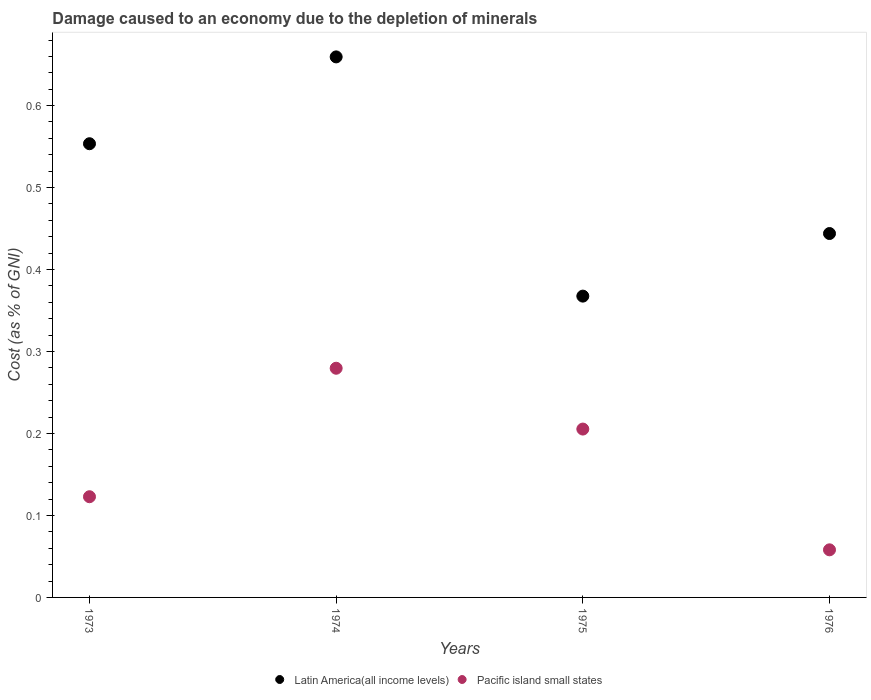Is the number of dotlines equal to the number of legend labels?
Provide a succinct answer. Yes. What is the cost of damage caused due to the depletion of minerals in Pacific island small states in 1976?
Provide a short and direct response. 0.06. Across all years, what is the maximum cost of damage caused due to the depletion of minerals in Latin America(all income levels)?
Your answer should be compact. 0.66. Across all years, what is the minimum cost of damage caused due to the depletion of minerals in Latin America(all income levels)?
Offer a terse response. 0.37. In which year was the cost of damage caused due to the depletion of minerals in Latin America(all income levels) maximum?
Your answer should be very brief. 1974. In which year was the cost of damage caused due to the depletion of minerals in Pacific island small states minimum?
Offer a very short reply. 1976. What is the total cost of damage caused due to the depletion of minerals in Latin America(all income levels) in the graph?
Provide a succinct answer. 2.02. What is the difference between the cost of damage caused due to the depletion of minerals in Latin America(all income levels) in 1973 and that in 1976?
Provide a succinct answer. 0.11. What is the difference between the cost of damage caused due to the depletion of minerals in Pacific island small states in 1973 and the cost of damage caused due to the depletion of minerals in Latin America(all income levels) in 1975?
Your response must be concise. -0.24. What is the average cost of damage caused due to the depletion of minerals in Pacific island small states per year?
Make the answer very short. 0.17. In the year 1976, what is the difference between the cost of damage caused due to the depletion of minerals in Pacific island small states and cost of damage caused due to the depletion of minerals in Latin America(all income levels)?
Provide a short and direct response. -0.39. What is the ratio of the cost of damage caused due to the depletion of minerals in Latin America(all income levels) in 1974 to that in 1975?
Keep it short and to the point. 1.79. What is the difference between the highest and the second highest cost of damage caused due to the depletion of minerals in Latin America(all income levels)?
Offer a terse response. 0.11. What is the difference between the highest and the lowest cost of damage caused due to the depletion of minerals in Latin America(all income levels)?
Ensure brevity in your answer.  0.29. In how many years, is the cost of damage caused due to the depletion of minerals in Pacific island small states greater than the average cost of damage caused due to the depletion of minerals in Pacific island small states taken over all years?
Give a very brief answer. 2. Is the cost of damage caused due to the depletion of minerals in Latin America(all income levels) strictly greater than the cost of damage caused due to the depletion of minerals in Pacific island small states over the years?
Offer a terse response. Yes. Does the graph contain any zero values?
Your answer should be compact. No. Where does the legend appear in the graph?
Make the answer very short. Bottom center. What is the title of the graph?
Provide a succinct answer. Damage caused to an economy due to the depletion of minerals. What is the label or title of the X-axis?
Your response must be concise. Years. What is the label or title of the Y-axis?
Your response must be concise. Cost (as % of GNI). What is the Cost (as % of GNI) in Latin America(all income levels) in 1973?
Keep it short and to the point. 0.55. What is the Cost (as % of GNI) of Pacific island small states in 1973?
Give a very brief answer. 0.12. What is the Cost (as % of GNI) in Latin America(all income levels) in 1974?
Your response must be concise. 0.66. What is the Cost (as % of GNI) in Pacific island small states in 1974?
Your answer should be compact. 0.28. What is the Cost (as % of GNI) of Latin America(all income levels) in 1975?
Offer a very short reply. 0.37. What is the Cost (as % of GNI) in Pacific island small states in 1975?
Keep it short and to the point. 0.21. What is the Cost (as % of GNI) of Latin America(all income levels) in 1976?
Give a very brief answer. 0.44. What is the Cost (as % of GNI) in Pacific island small states in 1976?
Offer a terse response. 0.06. Across all years, what is the maximum Cost (as % of GNI) in Latin America(all income levels)?
Your answer should be very brief. 0.66. Across all years, what is the maximum Cost (as % of GNI) of Pacific island small states?
Keep it short and to the point. 0.28. Across all years, what is the minimum Cost (as % of GNI) in Latin America(all income levels)?
Offer a very short reply. 0.37. Across all years, what is the minimum Cost (as % of GNI) of Pacific island small states?
Offer a very short reply. 0.06. What is the total Cost (as % of GNI) of Latin America(all income levels) in the graph?
Provide a succinct answer. 2.02. What is the total Cost (as % of GNI) in Pacific island small states in the graph?
Your answer should be very brief. 0.67. What is the difference between the Cost (as % of GNI) of Latin America(all income levels) in 1973 and that in 1974?
Provide a short and direct response. -0.11. What is the difference between the Cost (as % of GNI) of Pacific island small states in 1973 and that in 1974?
Make the answer very short. -0.16. What is the difference between the Cost (as % of GNI) of Latin America(all income levels) in 1973 and that in 1975?
Make the answer very short. 0.19. What is the difference between the Cost (as % of GNI) in Pacific island small states in 1973 and that in 1975?
Provide a short and direct response. -0.08. What is the difference between the Cost (as % of GNI) in Latin America(all income levels) in 1973 and that in 1976?
Offer a very short reply. 0.11. What is the difference between the Cost (as % of GNI) in Pacific island small states in 1973 and that in 1976?
Provide a succinct answer. 0.06. What is the difference between the Cost (as % of GNI) of Latin America(all income levels) in 1974 and that in 1975?
Ensure brevity in your answer.  0.29. What is the difference between the Cost (as % of GNI) of Pacific island small states in 1974 and that in 1975?
Your response must be concise. 0.07. What is the difference between the Cost (as % of GNI) of Latin America(all income levels) in 1974 and that in 1976?
Your answer should be very brief. 0.22. What is the difference between the Cost (as % of GNI) in Pacific island small states in 1974 and that in 1976?
Ensure brevity in your answer.  0.22. What is the difference between the Cost (as % of GNI) of Latin America(all income levels) in 1975 and that in 1976?
Offer a very short reply. -0.08. What is the difference between the Cost (as % of GNI) in Pacific island small states in 1975 and that in 1976?
Provide a succinct answer. 0.15. What is the difference between the Cost (as % of GNI) of Latin America(all income levels) in 1973 and the Cost (as % of GNI) of Pacific island small states in 1974?
Give a very brief answer. 0.27. What is the difference between the Cost (as % of GNI) of Latin America(all income levels) in 1973 and the Cost (as % of GNI) of Pacific island small states in 1975?
Make the answer very short. 0.35. What is the difference between the Cost (as % of GNI) in Latin America(all income levels) in 1973 and the Cost (as % of GNI) in Pacific island small states in 1976?
Give a very brief answer. 0.5. What is the difference between the Cost (as % of GNI) of Latin America(all income levels) in 1974 and the Cost (as % of GNI) of Pacific island small states in 1975?
Give a very brief answer. 0.45. What is the difference between the Cost (as % of GNI) in Latin America(all income levels) in 1974 and the Cost (as % of GNI) in Pacific island small states in 1976?
Your answer should be very brief. 0.6. What is the difference between the Cost (as % of GNI) of Latin America(all income levels) in 1975 and the Cost (as % of GNI) of Pacific island small states in 1976?
Offer a terse response. 0.31. What is the average Cost (as % of GNI) in Latin America(all income levels) per year?
Provide a succinct answer. 0.51. What is the average Cost (as % of GNI) in Pacific island small states per year?
Make the answer very short. 0.17. In the year 1973, what is the difference between the Cost (as % of GNI) in Latin America(all income levels) and Cost (as % of GNI) in Pacific island small states?
Offer a terse response. 0.43. In the year 1974, what is the difference between the Cost (as % of GNI) of Latin America(all income levels) and Cost (as % of GNI) of Pacific island small states?
Your answer should be very brief. 0.38. In the year 1975, what is the difference between the Cost (as % of GNI) in Latin America(all income levels) and Cost (as % of GNI) in Pacific island small states?
Your response must be concise. 0.16. In the year 1976, what is the difference between the Cost (as % of GNI) of Latin America(all income levels) and Cost (as % of GNI) of Pacific island small states?
Make the answer very short. 0.39. What is the ratio of the Cost (as % of GNI) of Latin America(all income levels) in 1973 to that in 1974?
Make the answer very short. 0.84. What is the ratio of the Cost (as % of GNI) in Pacific island small states in 1973 to that in 1974?
Ensure brevity in your answer.  0.44. What is the ratio of the Cost (as % of GNI) of Latin America(all income levels) in 1973 to that in 1975?
Ensure brevity in your answer.  1.51. What is the ratio of the Cost (as % of GNI) in Pacific island small states in 1973 to that in 1975?
Ensure brevity in your answer.  0.6. What is the ratio of the Cost (as % of GNI) in Latin America(all income levels) in 1973 to that in 1976?
Provide a short and direct response. 1.25. What is the ratio of the Cost (as % of GNI) of Pacific island small states in 1973 to that in 1976?
Make the answer very short. 2.12. What is the ratio of the Cost (as % of GNI) of Latin America(all income levels) in 1974 to that in 1975?
Provide a short and direct response. 1.79. What is the ratio of the Cost (as % of GNI) in Pacific island small states in 1974 to that in 1975?
Offer a terse response. 1.36. What is the ratio of the Cost (as % of GNI) in Latin America(all income levels) in 1974 to that in 1976?
Keep it short and to the point. 1.49. What is the ratio of the Cost (as % of GNI) in Pacific island small states in 1974 to that in 1976?
Your answer should be very brief. 4.81. What is the ratio of the Cost (as % of GNI) of Latin America(all income levels) in 1975 to that in 1976?
Give a very brief answer. 0.83. What is the ratio of the Cost (as % of GNI) in Pacific island small states in 1975 to that in 1976?
Keep it short and to the point. 3.54. What is the difference between the highest and the second highest Cost (as % of GNI) of Latin America(all income levels)?
Provide a short and direct response. 0.11. What is the difference between the highest and the second highest Cost (as % of GNI) of Pacific island small states?
Provide a short and direct response. 0.07. What is the difference between the highest and the lowest Cost (as % of GNI) in Latin America(all income levels)?
Provide a succinct answer. 0.29. What is the difference between the highest and the lowest Cost (as % of GNI) of Pacific island small states?
Offer a terse response. 0.22. 